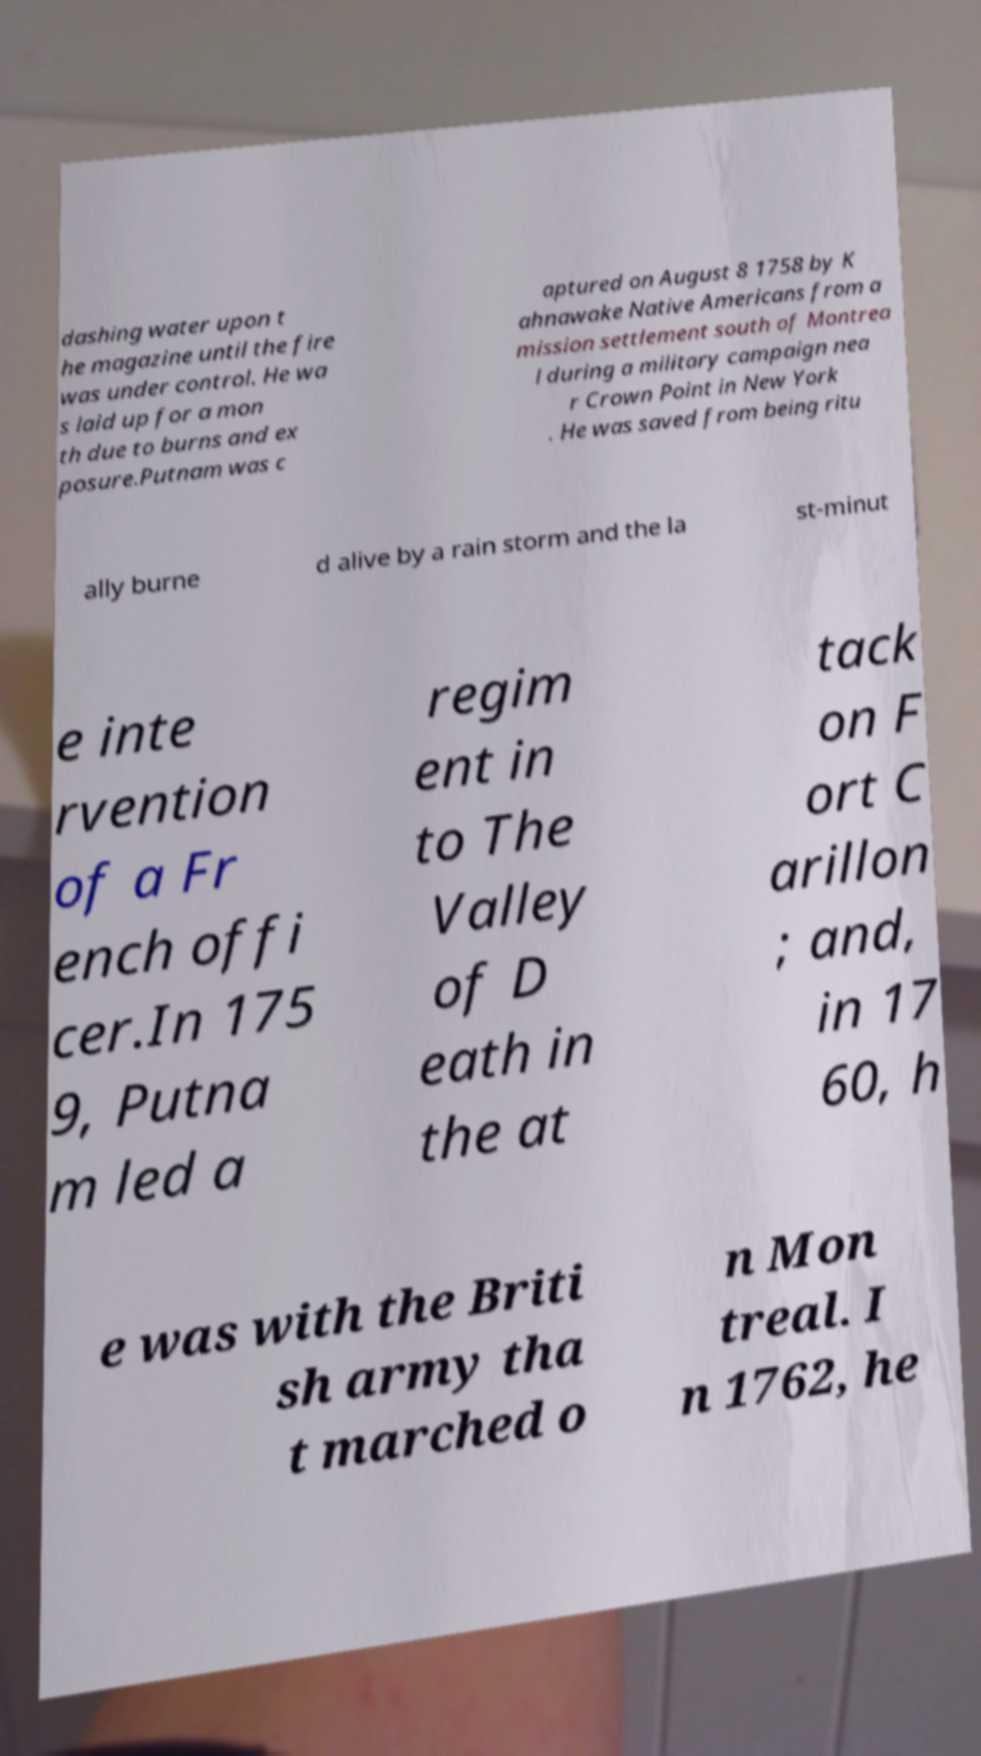I need the written content from this picture converted into text. Can you do that? dashing water upon t he magazine until the fire was under control. He wa s laid up for a mon th due to burns and ex posure.Putnam was c aptured on August 8 1758 by K ahnawake Native Americans from a mission settlement south of Montrea l during a military campaign nea r Crown Point in New York . He was saved from being ritu ally burne d alive by a rain storm and the la st-minut e inte rvention of a Fr ench offi cer.In 175 9, Putna m led a regim ent in to The Valley of D eath in the at tack on F ort C arillon ; and, in 17 60, h e was with the Briti sh army tha t marched o n Mon treal. I n 1762, he 